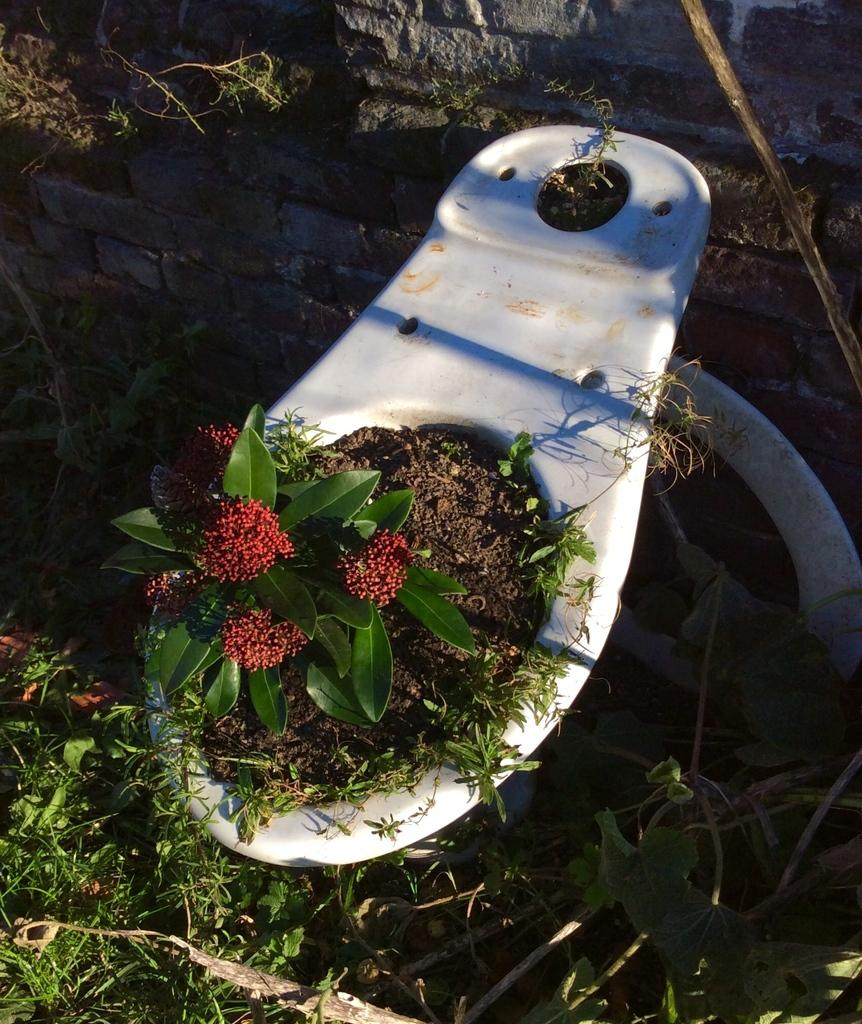What type of vegetation covers the ground in the image? The ground in the image is covered with grass. What can be seen in the middle of the image? There is an object in the middle of the image. What is inside the object? The object contains a plant. What type of flowers are on the plant? There are flowers on the plant. How many icicles are hanging from the plant in the image? There are no icicles present in the image; it features a plant with flowers. What time of day is depicted in the image? The provided facts do not mention the time of day, so it cannot be determined from the image. 